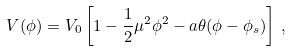Convert formula to latex. <formula><loc_0><loc_0><loc_500><loc_500>V ( \phi ) = V _ { 0 } \left [ 1 - \frac { 1 } { 2 } \mu ^ { 2 } \phi ^ { 2 } - a \theta ( \phi - \phi _ { s } ) \right ] \, ,</formula> 